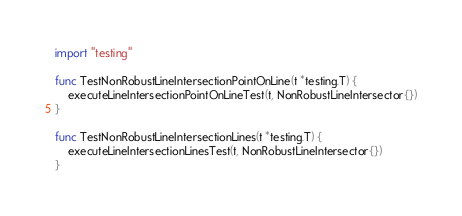<code> <loc_0><loc_0><loc_500><loc_500><_Go_>import "testing"

func TestNonRobustLineIntersectionPointOnLine(t *testing.T) {
	executeLineIntersectionPointOnLineTest(t, NonRobustLineIntersector{})
}

func TestNonRobustLineIntersectionLines(t *testing.T) {
	executeLineIntersectionLinesTest(t, NonRobustLineIntersector{})
}
</code> 